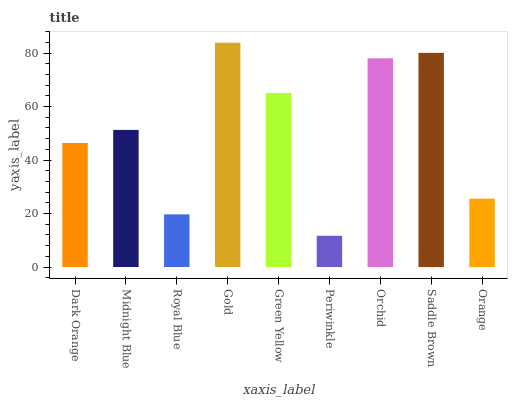Is Periwinkle the minimum?
Answer yes or no. Yes. Is Gold the maximum?
Answer yes or no. Yes. Is Midnight Blue the minimum?
Answer yes or no. No. Is Midnight Blue the maximum?
Answer yes or no. No. Is Midnight Blue greater than Dark Orange?
Answer yes or no. Yes. Is Dark Orange less than Midnight Blue?
Answer yes or no. Yes. Is Dark Orange greater than Midnight Blue?
Answer yes or no. No. Is Midnight Blue less than Dark Orange?
Answer yes or no. No. Is Midnight Blue the high median?
Answer yes or no. Yes. Is Midnight Blue the low median?
Answer yes or no. Yes. Is Periwinkle the high median?
Answer yes or no. No. Is Orchid the low median?
Answer yes or no. No. 